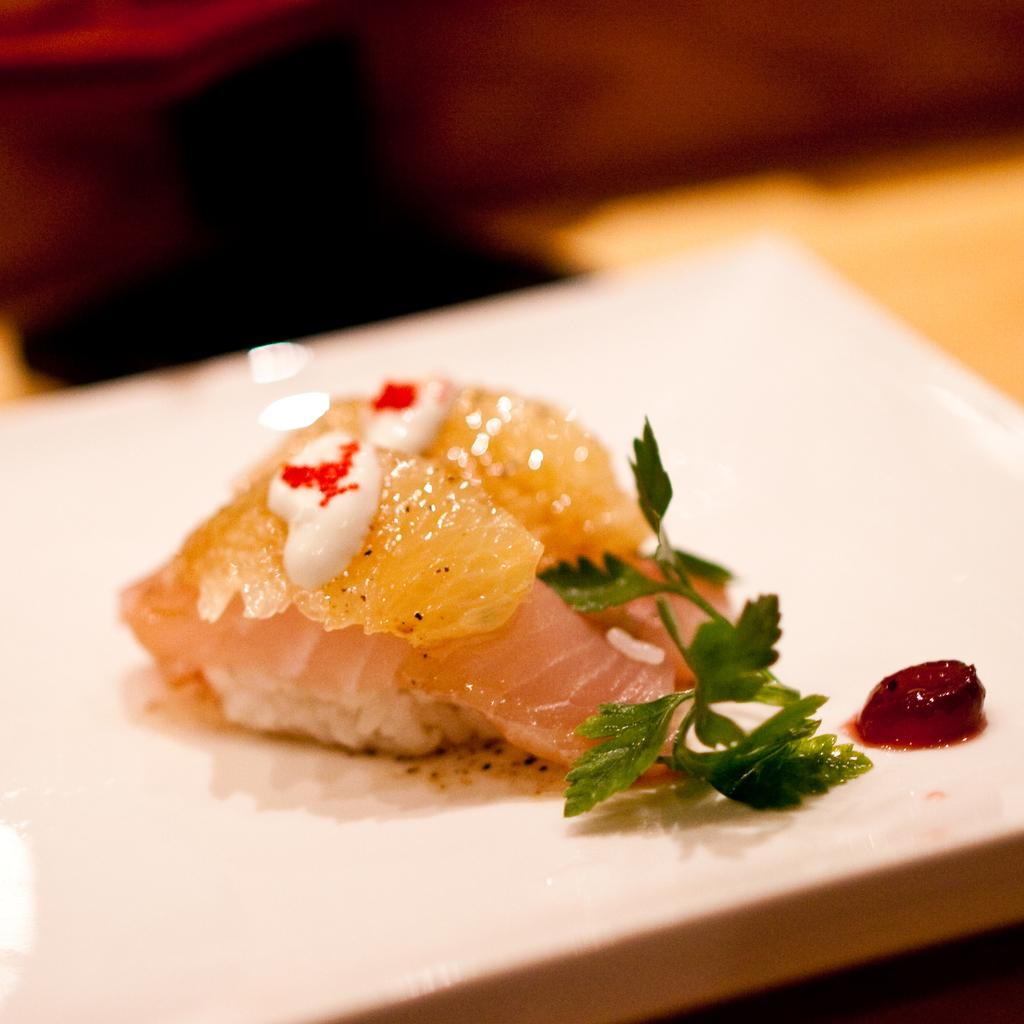What object is present on the plate in the image? There is a food item on the plate in the image. What color is the plate? The plate is white in color. What else is on the plate besides the food item? There are leaves on the plate. Can you describe the background of the image? The background of the image is blurred. How many clocks are visible on the plate in the image? There are no clocks visible on the plate in the image. Is there a sofa in the background of the image? There is no sofa present in the image; the background is blurred. 